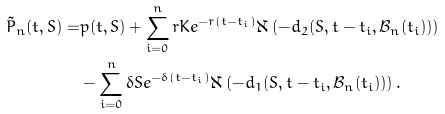<formula> <loc_0><loc_0><loc_500><loc_500>\tilde { P } _ { n } ( t , S ) = & p ( t , S ) + \sum _ { i = 0 } ^ { n } r K e ^ { - r ( t - t _ { i } ) } \aleph \left ( - d _ { 2 } ( S , t - t _ { i } , \mathcal { B } _ { n } ( t _ { i } ) ) \right ) \\ & - \sum _ { i = 0 } ^ { n } \delta S e ^ { - \delta ( t - t _ { i } ) } \aleph \left ( - d _ { 1 } ( S , t - t _ { i } , \mathcal { B } _ { n } ( t _ { i } ) ) \right ) .</formula> 